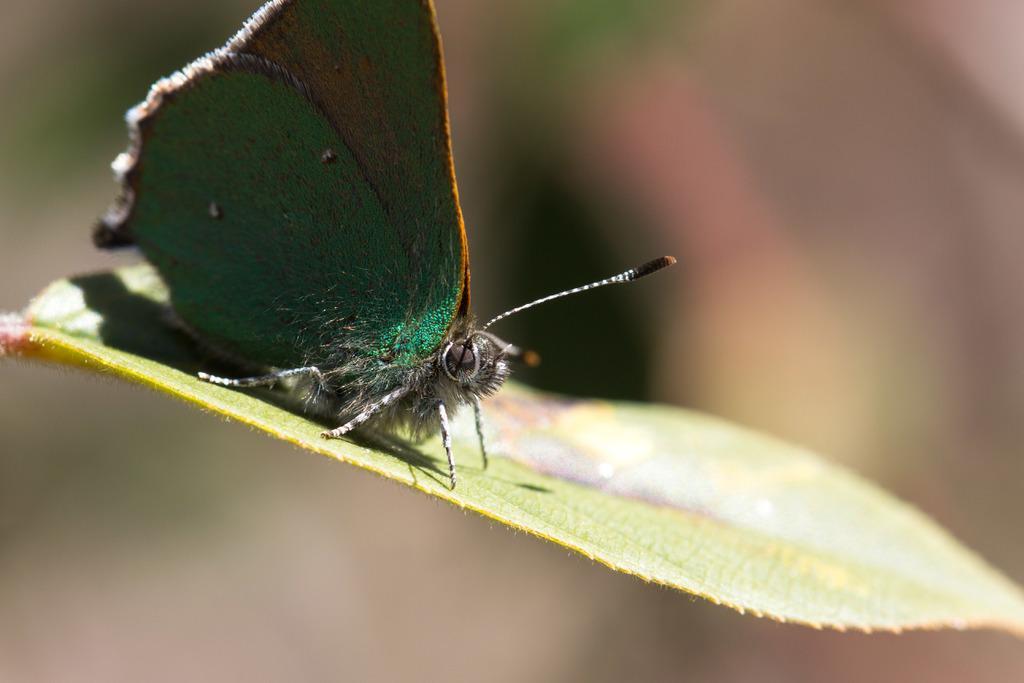Can you describe this image briefly? In this image we can see a butterfly on the leaf and the background is not clear. 